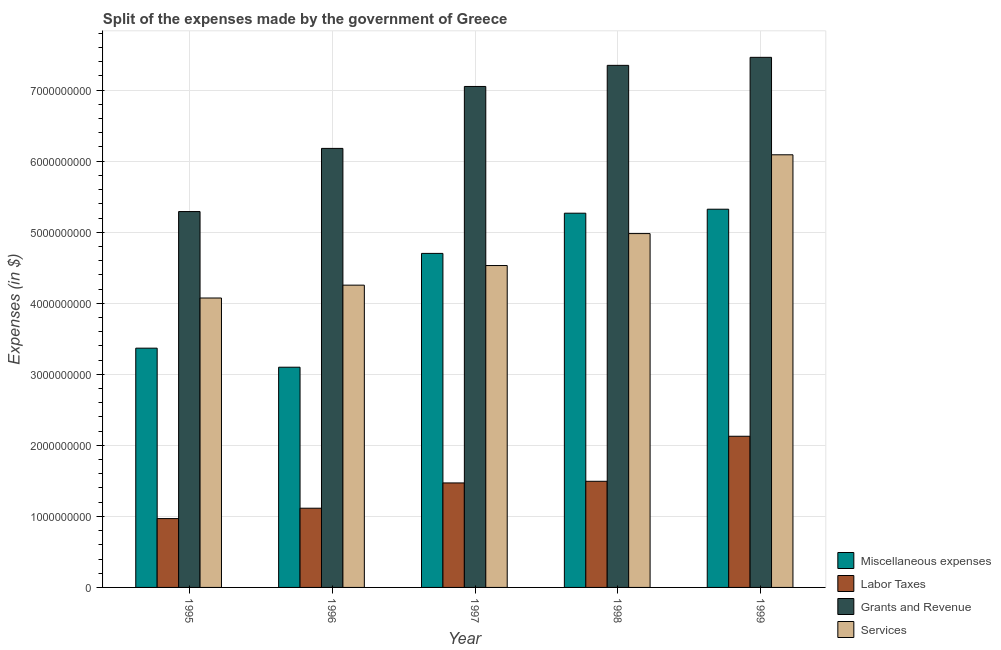How many different coloured bars are there?
Ensure brevity in your answer.  4. How many groups of bars are there?
Your answer should be very brief. 5. Are the number of bars on each tick of the X-axis equal?
Your answer should be compact. Yes. In how many cases, is the number of bars for a given year not equal to the number of legend labels?
Your response must be concise. 0. What is the amount spent on miscellaneous expenses in 1995?
Provide a short and direct response. 3.37e+09. Across all years, what is the maximum amount spent on miscellaneous expenses?
Make the answer very short. 5.32e+09. Across all years, what is the minimum amount spent on services?
Keep it short and to the point. 4.07e+09. What is the total amount spent on labor taxes in the graph?
Provide a short and direct response. 7.18e+09. What is the difference between the amount spent on services in 1995 and that in 1997?
Your answer should be very brief. -4.57e+08. What is the difference between the amount spent on grants and revenue in 1998 and the amount spent on labor taxes in 1996?
Offer a very short reply. 1.17e+09. What is the average amount spent on miscellaneous expenses per year?
Keep it short and to the point. 4.35e+09. What is the ratio of the amount spent on services in 1996 to that in 1999?
Provide a succinct answer. 0.7. What is the difference between the highest and the second highest amount spent on miscellaneous expenses?
Keep it short and to the point. 5.60e+07. What is the difference between the highest and the lowest amount spent on grants and revenue?
Offer a terse response. 2.17e+09. In how many years, is the amount spent on labor taxes greater than the average amount spent on labor taxes taken over all years?
Offer a very short reply. 3. What does the 2nd bar from the left in 1999 represents?
Your answer should be compact. Labor Taxes. What does the 1st bar from the right in 1997 represents?
Your answer should be compact. Services. Is it the case that in every year, the sum of the amount spent on miscellaneous expenses and amount spent on labor taxes is greater than the amount spent on grants and revenue?
Make the answer very short. No. How many bars are there?
Your response must be concise. 20. Are all the bars in the graph horizontal?
Give a very brief answer. No. What is the difference between two consecutive major ticks on the Y-axis?
Give a very brief answer. 1.00e+09. Does the graph contain any zero values?
Provide a succinct answer. No. Where does the legend appear in the graph?
Provide a succinct answer. Bottom right. How many legend labels are there?
Your answer should be compact. 4. How are the legend labels stacked?
Offer a terse response. Vertical. What is the title of the graph?
Make the answer very short. Split of the expenses made by the government of Greece. What is the label or title of the Y-axis?
Keep it short and to the point. Expenses (in $). What is the Expenses (in $) in Miscellaneous expenses in 1995?
Give a very brief answer. 3.37e+09. What is the Expenses (in $) in Labor Taxes in 1995?
Provide a short and direct response. 9.69e+08. What is the Expenses (in $) of Grants and Revenue in 1995?
Your answer should be compact. 5.29e+09. What is the Expenses (in $) of Services in 1995?
Offer a very short reply. 4.07e+09. What is the Expenses (in $) of Miscellaneous expenses in 1996?
Give a very brief answer. 3.10e+09. What is the Expenses (in $) in Labor Taxes in 1996?
Your response must be concise. 1.12e+09. What is the Expenses (in $) in Grants and Revenue in 1996?
Keep it short and to the point. 6.18e+09. What is the Expenses (in $) of Services in 1996?
Make the answer very short. 4.26e+09. What is the Expenses (in $) in Miscellaneous expenses in 1997?
Give a very brief answer. 4.70e+09. What is the Expenses (in $) in Labor Taxes in 1997?
Make the answer very short. 1.47e+09. What is the Expenses (in $) of Grants and Revenue in 1997?
Make the answer very short. 7.05e+09. What is the Expenses (in $) of Services in 1997?
Your answer should be compact. 4.53e+09. What is the Expenses (in $) of Miscellaneous expenses in 1998?
Offer a terse response. 5.27e+09. What is the Expenses (in $) of Labor Taxes in 1998?
Ensure brevity in your answer.  1.49e+09. What is the Expenses (in $) in Grants and Revenue in 1998?
Offer a very short reply. 7.35e+09. What is the Expenses (in $) in Services in 1998?
Offer a terse response. 4.98e+09. What is the Expenses (in $) of Miscellaneous expenses in 1999?
Provide a short and direct response. 5.32e+09. What is the Expenses (in $) of Labor Taxes in 1999?
Provide a short and direct response. 2.13e+09. What is the Expenses (in $) of Grants and Revenue in 1999?
Provide a succinct answer. 7.46e+09. What is the Expenses (in $) in Services in 1999?
Offer a terse response. 6.09e+09. Across all years, what is the maximum Expenses (in $) in Miscellaneous expenses?
Keep it short and to the point. 5.32e+09. Across all years, what is the maximum Expenses (in $) in Labor Taxes?
Your response must be concise. 2.13e+09. Across all years, what is the maximum Expenses (in $) of Grants and Revenue?
Your answer should be compact. 7.46e+09. Across all years, what is the maximum Expenses (in $) in Services?
Ensure brevity in your answer.  6.09e+09. Across all years, what is the minimum Expenses (in $) of Miscellaneous expenses?
Provide a short and direct response. 3.10e+09. Across all years, what is the minimum Expenses (in $) of Labor Taxes?
Keep it short and to the point. 9.69e+08. Across all years, what is the minimum Expenses (in $) of Grants and Revenue?
Provide a succinct answer. 5.29e+09. Across all years, what is the minimum Expenses (in $) in Services?
Your answer should be compact. 4.07e+09. What is the total Expenses (in $) in Miscellaneous expenses in the graph?
Your answer should be compact. 2.18e+1. What is the total Expenses (in $) of Labor Taxes in the graph?
Your answer should be compact. 7.18e+09. What is the total Expenses (in $) in Grants and Revenue in the graph?
Provide a short and direct response. 3.33e+1. What is the total Expenses (in $) in Services in the graph?
Make the answer very short. 2.39e+1. What is the difference between the Expenses (in $) in Miscellaneous expenses in 1995 and that in 1996?
Your answer should be compact. 2.68e+08. What is the difference between the Expenses (in $) in Labor Taxes in 1995 and that in 1996?
Your answer should be compact. -1.46e+08. What is the difference between the Expenses (in $) in Grants and Revenue in 1995 and that in 1996?
Provide a short and direct response. -8.89e+08. What is the difference between the Expenses (in $) in Services in 1995 and that in 1996?
Provide a succinct answer. -1.81e+08. What is the difference between the Expenses (in $) in Miscellaneous expenses in 1995 and that in 1997?
Keep it short and to the point. -1.33e+09. What is the difference between the Expenses (in $) in Labor Taxes in 1995 and that in 1997?
Your answer should be very brief. -5.02e+08. What is the difference between the Expenses (in $) in Grants and Revenue in 1995 and that in 1997?
Make the answer very short. -1.76e+09. What is the difference between the Expenses (in $) in Services in 1995 and that in 1997?
Offer a terse response. -4.57e+08. What is the difference between the Expenses (in $) of Miscellaneous expenses in 1995 and that in 1998?
Offer a terse response. -1.90e+09. What is the difference between the Expenses (in $) of Labor Taxes in 1995 and that in 1998?
Keep it short and to the point. -5.25e+08. What is the difference between the Expenses (in $) of Grants and Revenue in 1995 and that in 1998?
Make the answer very short. -2.06e+09. What is the difference between the Expenses (in $) of Services in 1995 and that in 1998?
Ensure brevity in your answer.  -9.07e+08. What is the difference between the Expenses (in $) in Miscellaneous expenses in 1995 and that in 1999?
Provide a succinct answer. -1.96e+09. What is the difference between the Expenses (in $) of Labor Taxes in 1995 and that in 1999?
Provide a succinct answer. -1.16e+09. What is the difference between the Expenses (in $) in Grants and Revenue in 1995 and that in 1999?
Ensure brevity in your answer.  -2.17e+09. What is the difference between the Expenses (in $) in Services in 1995 and that in 1999?
Offer a terse response. -2.02e+09. What is the difference between the Expenses (in $) in Miscellaneous expenses in 1996 and that in 1997?
Your answer should be compact. -1.60e+09. What is the difference between the Expenses (in $) of Labor Taxes in 1996 and that in 1997?
Provide a succinct answer. -3.56e+08. What is the difference between the Expenses (in $) in Grants and Revenue in 1996 and that in 1997?
Offer a terse response. -8.72e+08. What is the difference between the Expenses (in $) in Services in 1996 and that in 1997?
Offer a terse response. -2.76e+08. What is the difference between the Expenses (in $) in Miscellaneous expenses in 1996 and that in 1998?
Keep it short and to the point. -2.17e+09. What is the difference between the Expenses (in $) of Labor Taxes in 1996 and that in 1998?
Ensure brevity in your answer.  -3.79e+08. What is the difference between the Expenses (in $) in Grants and Revenue in 1996 and that in 1998?
Provide a short and direct response. -1.17e+09. What is the difference between the Expenses (in $) of Services in 1996 and that in 1998?
Offer a terse response. -7.26e+08. What is the difference between the Expenses (in $) of Miscellaneous expenses in 1996 and that in 1999?
Provide a short and direct response. -2.22e+09. What is the difference between the Expenses (in $) in Labor Taxes in 1996 and that in 1999?
Your response must be concise. -1.01e+09. What is the difference between the Expenses (in $) in Grants and Revenue in 1996 and that in 1999?
Provide a succinct answer. -1.28e+09. What is the difference between the Expenses (in $) of Services in 1996 and that in 1999?
Give a very brief answer. -1.84e+09. What is the difference between the Expenses (in $) in Miscellaneous expenses in 1997 and that in 1998?
Keep it short and to the point. -5.66e+08. What is the difference between the Expenses (in $) in Labor Taxes in 1997 and that in 1998?
Your response must be concise. -2.30e+07. What is the difference between the Expenses (in $) of Grants and Revenue in 1997 and that in 1998?
Provide a succinct answer. -2.97e+08. What is the difference between the Expenses (in $) of Services in 1997 and that in 1998?
Your answer should be compact. -4.50e+08. What is the difference between the Expenses (in $) in Miscellaneous expenses in 1997 and that in 1999?
Give a very brief answer. -6.22e+08. What is the difference between the Expenses (in $) in Labor Taxes in 1997 and that in 1999?
Your answer should be compact. -6.57e+08. What is the difference between the Expenses (in $) in Grants and Revenue in 1997 and that in 1999?
Keep it short and to the point. -4.10e+08. What is the difference between the Expenses (in $) in Services in 1997 and that in 1999?
Give a very brief answer. -1.56e+09. What is the difference between the Expenses (in $) of Miscellaneous expenses in 1998 and that in 1999?
Your answer should be compact. -5.60e+07. What is the difference between the Expenses (in $) of Labor Taxes in 1998 and that in 1999?
Your answer should be compact. -6.34e+08. What is the difference between the Expenses (in $) in Grants and Revenue in 1998 and that in 1999?
Provide a succinct answer. -1.13e+08. What is the difference between the Expenses (in $) in Services in 1998 and that in 1999?
Make the answer very short. -1.11e+09. What is the difference between the Expenses (in $) of Miscellaneous expenses in 1995 and the Expenses (in $) of Labor Taxes in 1996?
Offer a very short reply. 2.25e+09. What is the difference between the Expenses (in $) in Miscellaneous expenses in 1995 and the Expenses (in $) in Grants and Revenue in 1996?
Make the answer very short. -2.81e+09. What is the difference between the Expenses (in $) in Miscellaneous expenses in 1995 and the Expenses (in $) in Services in 1996?
Offer a very short reply. -8.87e+08. What is the difference between the Expenses (in $) of Labor Taxes in 1995 and the Expenses (in $) of Grants and Revenue in 1996?
Your answer should be compact. -5.21e+09. What is the difference between the Expenses (in $) of Labor Taxes in 1995 and the Expenses (in $) of Services in 1996?
Your answer should be very brief. -3.29e+09. What is the difference between the Expenses (in $) of Grants and Revenue in 1995 and the Expenses (in $) of Services in 1996?
Provide a succinct answer. 1.04e+09. What is the difference between the Expenses (in $) of Miscellaneous expenses in 1995 and the Expenses (in $) of Labor Taxes in 1997?
Your answer should be very brief. 1.90e+09. What is the difference between the Expenses (in $) in Miscellaneous expenses in 1995 and the Expenses (in $) in Grants and Revenue in 1997?
Provide a short and direct response. -3.68e+09. What is the difference between the Expenses (in $) of Miscellaneous expenses in 1995 and the Expenses (in $) of Services in 1997?
Keep it short and to the point. -1.16e+09. What is the difference between the Expenses (in $) in Labor Taxes in 1995 and the Expenses (in $) in Grants and Revenue in 1997?
Give a very brief answer. -6.08e+09. What is the difference between the Expenses (in $) of Labor Taxes in 1995 and the Expenses (in $) of Services in 1997?
Your answer should be very brief. -3.56e+09. What is the difference between the Expenses (in $) of Grants and Revenue in 1995 and the Expenses (in $) of Services in 1997?
Your answer should be very brief. 7.60e+08. What is the difference between the Expenses (in $) of Miscellaneous expenses in 1995 and the Expenses (in $) of Labor Taxes in 1998?
Offer a very short reply. 1.87e+09. What is the difference between the Expenses (in $) of Miscellaneous expenses in 1995 and the Expenses (in $) of Grants and Revenue in 1998?
Give a very brief answer. -3.98e+09. What is the difference between the Expenses (in $) of Miscellaneous expenses in 1995 and the Expenses (in $) of Services in 1998?
Offer a terse response. -1.61e+09. What is the difference between the Expenses (in $) of Labor Taxes in 1995 and the Expenses (in $) of Grants and Revenue in 1998?
Your answer should be compact. -6.38e+09. What is the difference between the Expenses (in $) of Labor Taxes in 1995 and the Expenses (in $) of Services in 1998?
Offer a terse response. -4.01e+09. What is the difference between the Expenses (in $) of Grants and Revenue in 1995 and the Expenses (in $) of Services in 1998?
Your answer should be very brief. 3.10e+08. What is the difference between the Expenses (in $) in Miscellaneous expenses in 1995 and the Expenses (in $) in Labor Taxes in 1999?
Provide a succinct answer. 1.24e+09. What is the difference between the Expenses (in $) in Miscellaneous expenses in 1995 and the Expenses (in $) in Grants and Revenue in 1999?
Your answer should be compact. -4.09e+09. What is the difference between the Expenses (in $) of Miscellaneous expenses in 1995 and the Expenses (in $) of Services in 1999?
Ensure brevity in your answer.  -2.72e+09. What is the difference between the Expenses (in $) in Labor Taxes in 1995 and the Expenses (in $) in Grants and Revenue in 1999?
Your answer should be compact. -6.49e+09. What is the difference between the Expenses (in $) in Labor Taxes in 1995 and the Expenses (in $) in Services in 1999?
Your response must be concise. -5.12e+09. What is the difference between the Expenses (in $) of Grants and Revenue in 1995 and the Expenses (in $) of Services in 1999?
Ensure brevity in your answer.  -7.99e+08. What is the difference between the Expenses (in $) of Miscellaneous expenses in 1996 and the Expenses (in $) of Labor Taxes in 1997?
Provide a short and direct response. 1.63e+09. What is the difference between the Expenses (in $) in Miscellaneous expenses in 1996 and the Expenses (in $) in Grants and Revenue in 1997?
Offer a very short reply. -3.95e+09. What is the difference between the Expenses (in $) of Miscellaneous expenses in 1996 and the Expenses (in $) of Services in 1997?
Your response must be concise. -1.43e+09. What is the difference between the Expenses (in $) in Labor Taxes in 1996 and the Expenses (in $) in Grants and Revenue in 1997?
Your answer should be compact. -5.94e+09. What is the difference between the Expenses (in $) of Labor Taxes in 1996 and the Expenses (in $) of Services in 1997?
Provide a short and direct response. -3.42e+09. What is the difference between the Expenses (in $) in Grants and Revenue in 1996 and the Expenses (in $) in Services in 1997?
Give a very brief answer. 1.65e+09. What is the difference between the Expenses (in $) in Miscellaneous expenses in 1996 and the Expenses (in $) in Labor Taxes in 1998?
Offer a very short reply. 1.61e+09. What is the difference between the Expenses (in $) of Miscellaneous expenses in 1996 and the Expenses (in $) of Grants and Revenue in 1998?
Provide a short and direct response. -4.25e+09. What is the difference between the Expenses (in $) in Miscellaneous expenses in 1996 and the Expenses (in $) in Services in 1998?
Offer a terse response. -1.88e+09. What is the difference between the Expenses (in $) of Labor Taxes in 1996 and the Expenses (in $) of Grants and Revenue in 1998?
Your answer should be compact. -6.23e+09. What is the difference between the Expenses (in $) in Labor Taxes in 1996 and the Expenses (in $) in Services in 1998?
Provide a succinct answer. -3.87e+09. What is the difference between the Expenses (in $) of Grants and Revenue in 1996 and the Expenses (in $) of Services in 1998?
Provide a short and direct response. 1.20e+09. What is the difference between the Expenses (in $) of Miscellaneous expenses in 1996 and the Expenses (in $) of Labor Taxes in 1999?
Ensure brevity in your answer.  9.72e+08. What is the difference between the Expenses (in $) of Miscellaneous expenses in 1996 and the Expenses (in $) of Grants and Revenue in 1999?
Your answer should be very brief. -4.36e+09. What is the difference between the Expenses (in $) in Miscellaneous expenses in 1996 and the Expenses (in $) in Services in 1999?
Your answer should be compact. -2.99e+09. What is the difference between the Expenses (in $) of Labor Taxes in 1996 and the Expenses (in $) of Grants and Revenue in 1999?
Make the answer very short. -6.35e+09. What is the difference between the Expenses (in $) in Labor Taxes in 1996 and the Expenses (in $) in Services in 1999?
Make the answer very short. -4.98e+09. What is the difference between the Expenses (in $) in Grants and Revenue in 1996 and the Expenses (in $) in Services in 1999?
Offer a terse response. 9.00e+07. What is the difference between the Expenses (in $) of Miscellaneous expenses in 1997 and the Expenses (in $) of Labor Taxes in 1998?
Offer a very short reply. 3.21e+09. What is the difference between the Expenses (in $) in Miscellaneous expenses in 1997 and the Expenses (in $) in Grants and Revenue in 1998?
Your answer should be very brief. -2.65e+09. What is the difference between the Expenses (in $) in Miscellaneous expenses in 1997 and the Expenses (in $) in Services in 1998?
Keep it short and to the point. -2.79e+08. What is the difference between the Expenses (in $) in Labor Taxes in 1997 and the Expenses (in $) in Grants and Revenue in 1998?
Give a very brief answer. -5.88e+09. What is the difference between the Expenses (in $) of Labor Taxes in 1997 and the Expenses (in $) of Services in 1998?
Your answer should be compact. -3.51e+09. What is the difference between the Expenses (in $) in Grants and Revenue in 1997 and the Expenses (in $) in Services in 1998?
Keep it short and to the point. 2.07e+09. What is the difference between the Expenses (in $) in Miscellaneous expenses in 1997 and the Expenses (in $) in Labor Taxes in 1999?
Keep it short and to the point. 2.57e+09. What is the difference between the Expenses (in $) in Miscellaneous expenses in 1997 and the Expenses (in $) in Grants and Revenue in 1999?
Offer a terse response. -2.76e+09. What is the difference between the Expenses (in $) in Miscellaneous expenses in 1997 and the Expenses (in $) in Services in 1999?
Provide a short and direct response. -1.39e+09. What is the difference between the Expenses (in $) of Labor Taxes in 1997 and the Expenses (in $) of Grants and Revenue in 1999?
Offer a very short reply. -5.99e+09. What is the difference between the Expenses (in $) in Labor Taxes in 1997 and the Expenses (in $) in Services in 1999?
Keep it short and to the point. -4.62e+09. What is the difference between the Expenses (in $) of Grants and Revenue in 1997 and the Expenses (in $) of Services in 1999?
Provide a short and direct response. 9.62e+08. What is the difference between the Expenses (in $) in Miscellaneous expenses in 1998 and the Expenses (in $) in Labor Taxes in 1999?
Provide a short and direct response. 3.14e+09. What is the difference between the Expenses (in $) in Miscellaneous expenses in 1998 and the Expenses (in $) in Grants and Revenue in 1999?
Your answer should be compact. -2.19e+09. What is the difference between the Expenses (in $) of Miscellaneous expenses in 1998 and the Expenses (in $) of Services in 1999?
Offer a terse response. -8.22e+08. What is the difference between the Expenses (in $) of Labor Taxes in 1998 and the Expenses (in $) of Grants and Revenue in 1999?
Your answer should be compact. -5.97e+09. What is the difference between the Expenses (in $) in Labor Taxes in 1998 and the Expenses (in $) in Services in 1999?
Ensure brevity in your answer.  -4.60e+09. What is the difference between the Expenses (in $) of Grants and Revenue in 1998 and the Expenses (in $) of Services in 1999?
Ensure brevity in your answer.  1.26e+09. What is the average Expenses (in $) of Miscellaneous expenses per year?
Your response must be concise. 4.35e+09. What is the average Expenses (in $) of Labor Taxes per year?
Provide a short and direct response. 1.44e+09. What is the average Expenses (in $) in Grants and Revenue per year?
Ensure brevity in your answer.  6.67e+09. What is the average Expenses (in $) of Services per year?
Provide a short and direct response. 4.79e+09. In the year 1995, what is the difference between the Expenses (in $) of Miscellaneous expenses and Expenses (in $) of Labor Taxes?
Offer a very short reply. 2.40e+09. In the year 1995, what is the difference between the Expenses (in $) of Miscellaneous expenses and Expenses (in $) of Grants and Revenue?
Your response must be concise. -1.92e+09. In the year 1995, what is the difference between the Expenses (in $) of Miscellaneous expenses and Expenses (in $) of Services?
Keep it short and to the point. -7.06e+08. In the year 1995, what is the difference between the Expenses (in $) in Labor Taxes and Expenses (in $) in Grants and Revenue?
Your answer should be compact. -4.32e+09. In the year 1995, what is the difference between the Expenses (in $) in Labor Taxes and Expenses (in $) in Services?
Provide a short and direct response. -3.10e+09. In the year 1995, what is the difference between the Expenses (in $) of Grants and Revenue and Expenses (in $) of Services?
Make the answer very short. 1.22e+09. In the year 1996, what is the difference between the Expenses (in $) in Miscellaneous expenses and Expenses (in $) in Labor Taxes?
Offer a terse response. 1.98e+09. In the year 1996, what is the difference between the Expenses (in $) in Miscellaneous expenses and Expenses (in $) in Grants and Revenue?
Make the answer very short. -3.08e+09. In the year 1996, what is the difference between the Expenses (in $) of Miscellaneous expenses and Expenses (in $) of Services?
Your answer should be compact. -1.16e+09. In the year 1996, what is the difference between the Expenses (in $) in Labor Taxes and Expenses (in $) in Grants and Revenue?
Make the answer very short. -5.06e+09. In the year 1996, what is the difference between the Expenses (in $) of Labor Taxes and Expenses (in $) of Services?
Offer a very short reply. -3.14e+09. In the year 1996, what is the difference between the Expenses (in $) in Grants and Revenue and Expenses (in $) in Services?
Your answer should be very brief. 1.92e+09. In the year 1997, what is the difference between the Expenses (in $) of Miscellaneous expenses and Expenses (in $) of Labor Taxes?
Offer a terse response. 3.23e+09. In the year 1997, what is the difference between the Expenses (in $) of Miscellaneous expenses and Expenses (in $) of Grants and Revenue?
Give a very brief answer. -2.35e+09. In the year 1997, what is the difference between the Expenses (in $) in Miscellaneous expenses and Expenses (in $) in Services?
Your answer should be very brief. 1.71e+08. In the year 1997, what is the difference between the Expenses (in $) in Labor Taxes and Expenses (in $) in Grants and Revenue?
Your answer should be very brief. -5.58e+09. In the year 1997, what is the difference between the Expenses (in $) of Labor Taxes and Expenses (in $) of Services?
Your answer should be very brief. -3.06e+09. In the year 1997, what is the difference between the Expenses (in $) of Grants and Revenue and Expenses (in $) of Services?
Your answer should be compact. 2.52e+09. In the year 1998, what is the difference between the Expenses (in $) in Miscellaneous expenses and Expenses (in $) in Labor Taxes?
Your answer should be very brief. 3.77e+09. In the year 1998, what is the difference between the Expenses (in $) in Miscellaneous expenses and Expenses (in $) in Grants and Revenue?
Provide a succinct answer. -2.08e+09. In the year 1998, what is the difference between the Expenses (in $) in Miscellaneous expenses and Expenses (in $) in Services?
Give a very brief answer. 2.87e+08. In the year 1998, what is the difference between the Expenses (in $) in Labor Taxes and Expenses (in $) in Grants and Revenue?
Your response must be concise. -5.86e+09. In the year 1998, what is the difference between the Expenses (in $) in Labor Taxes and Expenses (in $) in Services?
Give a very brief answer. -3.49e+09. In the year 1998, what is the difference between the Expenses (in $) in Grants and Revenue and Expenses (in $) in Services?
Your answer should be very brief. 2.37e+09. In the year 1999, what is the difference between the Expenses (in $) in Miscellaneous expenses and Expenses (in $) in Labor Taxes?
Ensure brevity in your answer.  3.20e+09. In the year 1999, what is the difference between the Expenses (in $) of Miscellaneous expenses and Expenses (in $) of Grants and Revenue?
Give a very brief answer. -2.14e+09. In the year 1999, what is the difference between the Expenses (in $) in Miscellaneous expenses and Expenses (in $) in Services?
Your answer should be very brief. -7.66e+08. In the year 1999, what is the difference between the Expenses (in $) of Labor Taxes and Expenses (in $) of Grants and Revenue?
Your answer should be compact. -5.33e+09. In the year 1999, what is the difference between the Expenses (in $) in Labor Taxes and Expenses (in $) in Services?
Provide a succinct answer. -3.96e+09. In the year 1999, what is the difference between the Expenses (in $) in Grants and Revenue and Expenses (in $) in Services?
Ensure brevity in your answer.  1.37e+09. What is the ratio of the Expenses (in $) of Miscellaneous expenses in 1995 to that in 1996?
Provide a succinct answer. 1.09. What is the ratio of the Expenses (in $) in Labor Taxes in 1995 to that in 1996?
Give a very brief answer. 0.87. What is the ratio of the Expenses (in $) of Grants and Revenue in 1995 to that in 1996?
Your response must be concise. 0.86. What is the ratio of the Expenses (in $) in Services in 1995 to that in 1996?
Make the answer very short. 0.96. What is the ratio of the Expenses (in $) of Miscellaneous expenses in 1995 to that in 1997?
Your answer should be very brief. 0.72. What is the ratio of the Expenses (in $) of Labor Taxes in 1995 to that in 1997?
Ensure brevity in your answer.  0.66. What is the ratio of the Expenses (in $) in Grants and Revenue in 1995 to that in 1997?
Ensure brevity in your answer.  0.75. What is the ratio of the Expenses (in $) in Services in 1995 to that in 1997?
Your answer should be very brief. 0.9. What is the ratio of the Expenses (in $) in Miscellaneous expenses in 1995 to that in 1998?
Your answer should be very brief. 0.64. What is the ratio of the Expenses (in $) of Labor Taxes in 1995 to that in 1998?
Your answer should be very brief. 0.65. What is the ratio of the Expenses (in $) of Grants and Revenue in 1995 to that in 1998?
Keep it short and to the point. 0.72. What is the ratio of the Expenses (in $) of Services in 1995 to that in 1998?
Your answer should be compact. 0.82. What is the ratio of the Expenses (in $) of Miscellaneous expenses in 1995 to that in 1999?
Your answer should be very brief. 0.63. What is the ratio of the Expenses (in $) of Labor Taxes in 1995 to that in 1999?
Ensure brevity in your answer.  0.46. What is the ratio of the Expenses (in $) in Grants and Revenue in 1995 to that in 1999?
Provide a succinct answer. 0.71. What is the ratio of the Expenses (in $) of Services in 1995 to that in 1999?
Your answer should be very brief. 0.67. What is the ratio of the Expenses (in $) of Miscellaneous expenses in 1996 to that in 1997?
Give a very brief answer. 0.66. What is the ratio of the Expenses (in $) of Labor Taxes in 1996 to that in 1997?
Your response must be concise. 0.76. What is the ratio of the Expenses (in $) in Grants and Revenue in 1996 to that in 1997?
Ensure brevity in your answer.  0.88. What is the ratio of the Expenses (in $) of Services in 1996 to that in 1997?
Ensure brevity in your answer.  0.94. What is the ratio of the Expenses (in $) in Miscellaneous expenses in 1996 to that in 1998?
Your answer should be compact. 0.59. What is the ratio of the Expenses (in $) in Labor Taxes in 1996 to that in 1998?
Provide a short and direct response. 0.75. What is the ratio of the Expenses (in $) in Grants and Revenue in 1996 to that in 1998?
Your answer should be compact. 0.84. What is the ratio of the Expenses (in $) of Services in 1996 to that in 1998?
Your answer should be compact. 0.85. What is the ratio of the Expenses (in $) of Miscellaneous expenses in 1996 to that in 1999?
Provide a short and direct response. 0.58. What is the ratio of the Expenses (in $) in Labor Taxes in 1996 to that in 1999?
Your answer should be very brief. 0.52. What is the ratio of the Expenses (in $) of Grants and Revenue in 1996 to that in 1999?
Offer a terse response. 0.83. What is the ratio of the Expenses (in $) of Services in 1996 to that in 1999?
Give a very brief answer. 0.7. What is the ratio of the Expenses (in $) in Miscellaneous expenses in 1997 to that in 1998?
Provide a succinct answer. 0.89. What is the ratio of the Expenses (in $) of Labor Taxes in 1997 to that in 1998?
Offer a very short reply. 0.98. What is the ratio of the Expenses (in $) of Grants and Revenue in 1997 to that in 1998?
Offer a terse response. 0.96. What is the ratio of the Expenses (in $) in Services in 1997 to that in 1998?
Offer a very short reply. 0.91. What is the ratio of the Expenses (in $) of Miscellaneous expenses in 1997 to that in 1999?
Keep it short and to the point. 0.88. What is the ratio of the Expenses (in $) in Labor Taxes in 1997 to that in 1999?
Give a very brief answer. 0.69. What is the ratio of the Expenses (in $) in Grants and Revenue in 1997 to that in 1999?
Your answer should be very brief. 0.95. What is the ratio of the Expenses (in $) of Services in 1997 to that in 1999?
Ensure brevity in your answer.  0.74. What is the ratio of the Expenses (in $) of Labor Taxes in 1998 to that in 1999?
Your answer should be very brief. 0.7. What is the ratio of the Expenses (in $) of Grants and Revenue in 1998 to that in 1999?
Your answer should be compact. 0.98. What is the ratio of the Expenses (in $) of Services in 1998 to that in 1999?
Your answer should be very brief. 0.82. What is the difference between the highest and the second highest Expenses (in $) of Miscellaneous expenses?
Ensure brevity in your answer.  5.60e+07. What is the difference between the highest and the second highest Expenses (in $) in Labor Taxes?
Ensure brevity in your answer.  6.34e+08. What is the difference between the highest and the second highest Expenses (in $) in Grants and Revenue?
Make the answer very short. 1.13e+08. What is the difference between the highest and the second highest Expenses (in $) of Services?
Provide a short and direct response. 1.11e+09. What is the difference between the highest and the lowest Expenses (in $) in Miscellaneous expenses?
Your response must be concise. 2.22e+09. What is the difference between the highest and the lowest Expenses (in $) in Labor Taxes?
Keep it short and to the point. 1.16e+09. What is the difference between the highest and the lowest Expenses (in $) of Grants and Revenue?
Your answer should be compact. 2.17e+09. What is the difference between the highest and the lowest Expenses (in $) of Services?
Keep it short and to the point. 2.02e+09. 